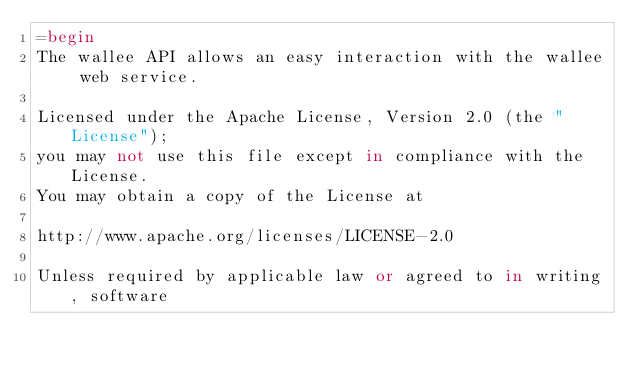Convert code to text. <code><loc_0><loc_0><loc_500><loc_500><_Ruby_>=begin
The wallee API allows an easy interaction with the wallee web service.

Licensed under the Apache License, Version 2.0 (the "License");
you may not use this file except in compliance with the License.
You may obtain a copy of the License at

http://www.apache.org/licenses/LICENSE-2.0

Unless required by applicable law or agreed to in writing, software</code> 